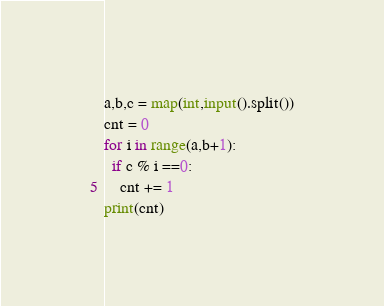<code> <loc_0><loc_0><loc_500><loc_500><_Python_>a,b,c = map(int,input().split())
cnt = 0
for i in range(a,b+1):
  if c % i ==0:
    cnt += 1
print(cnt)
</code> 